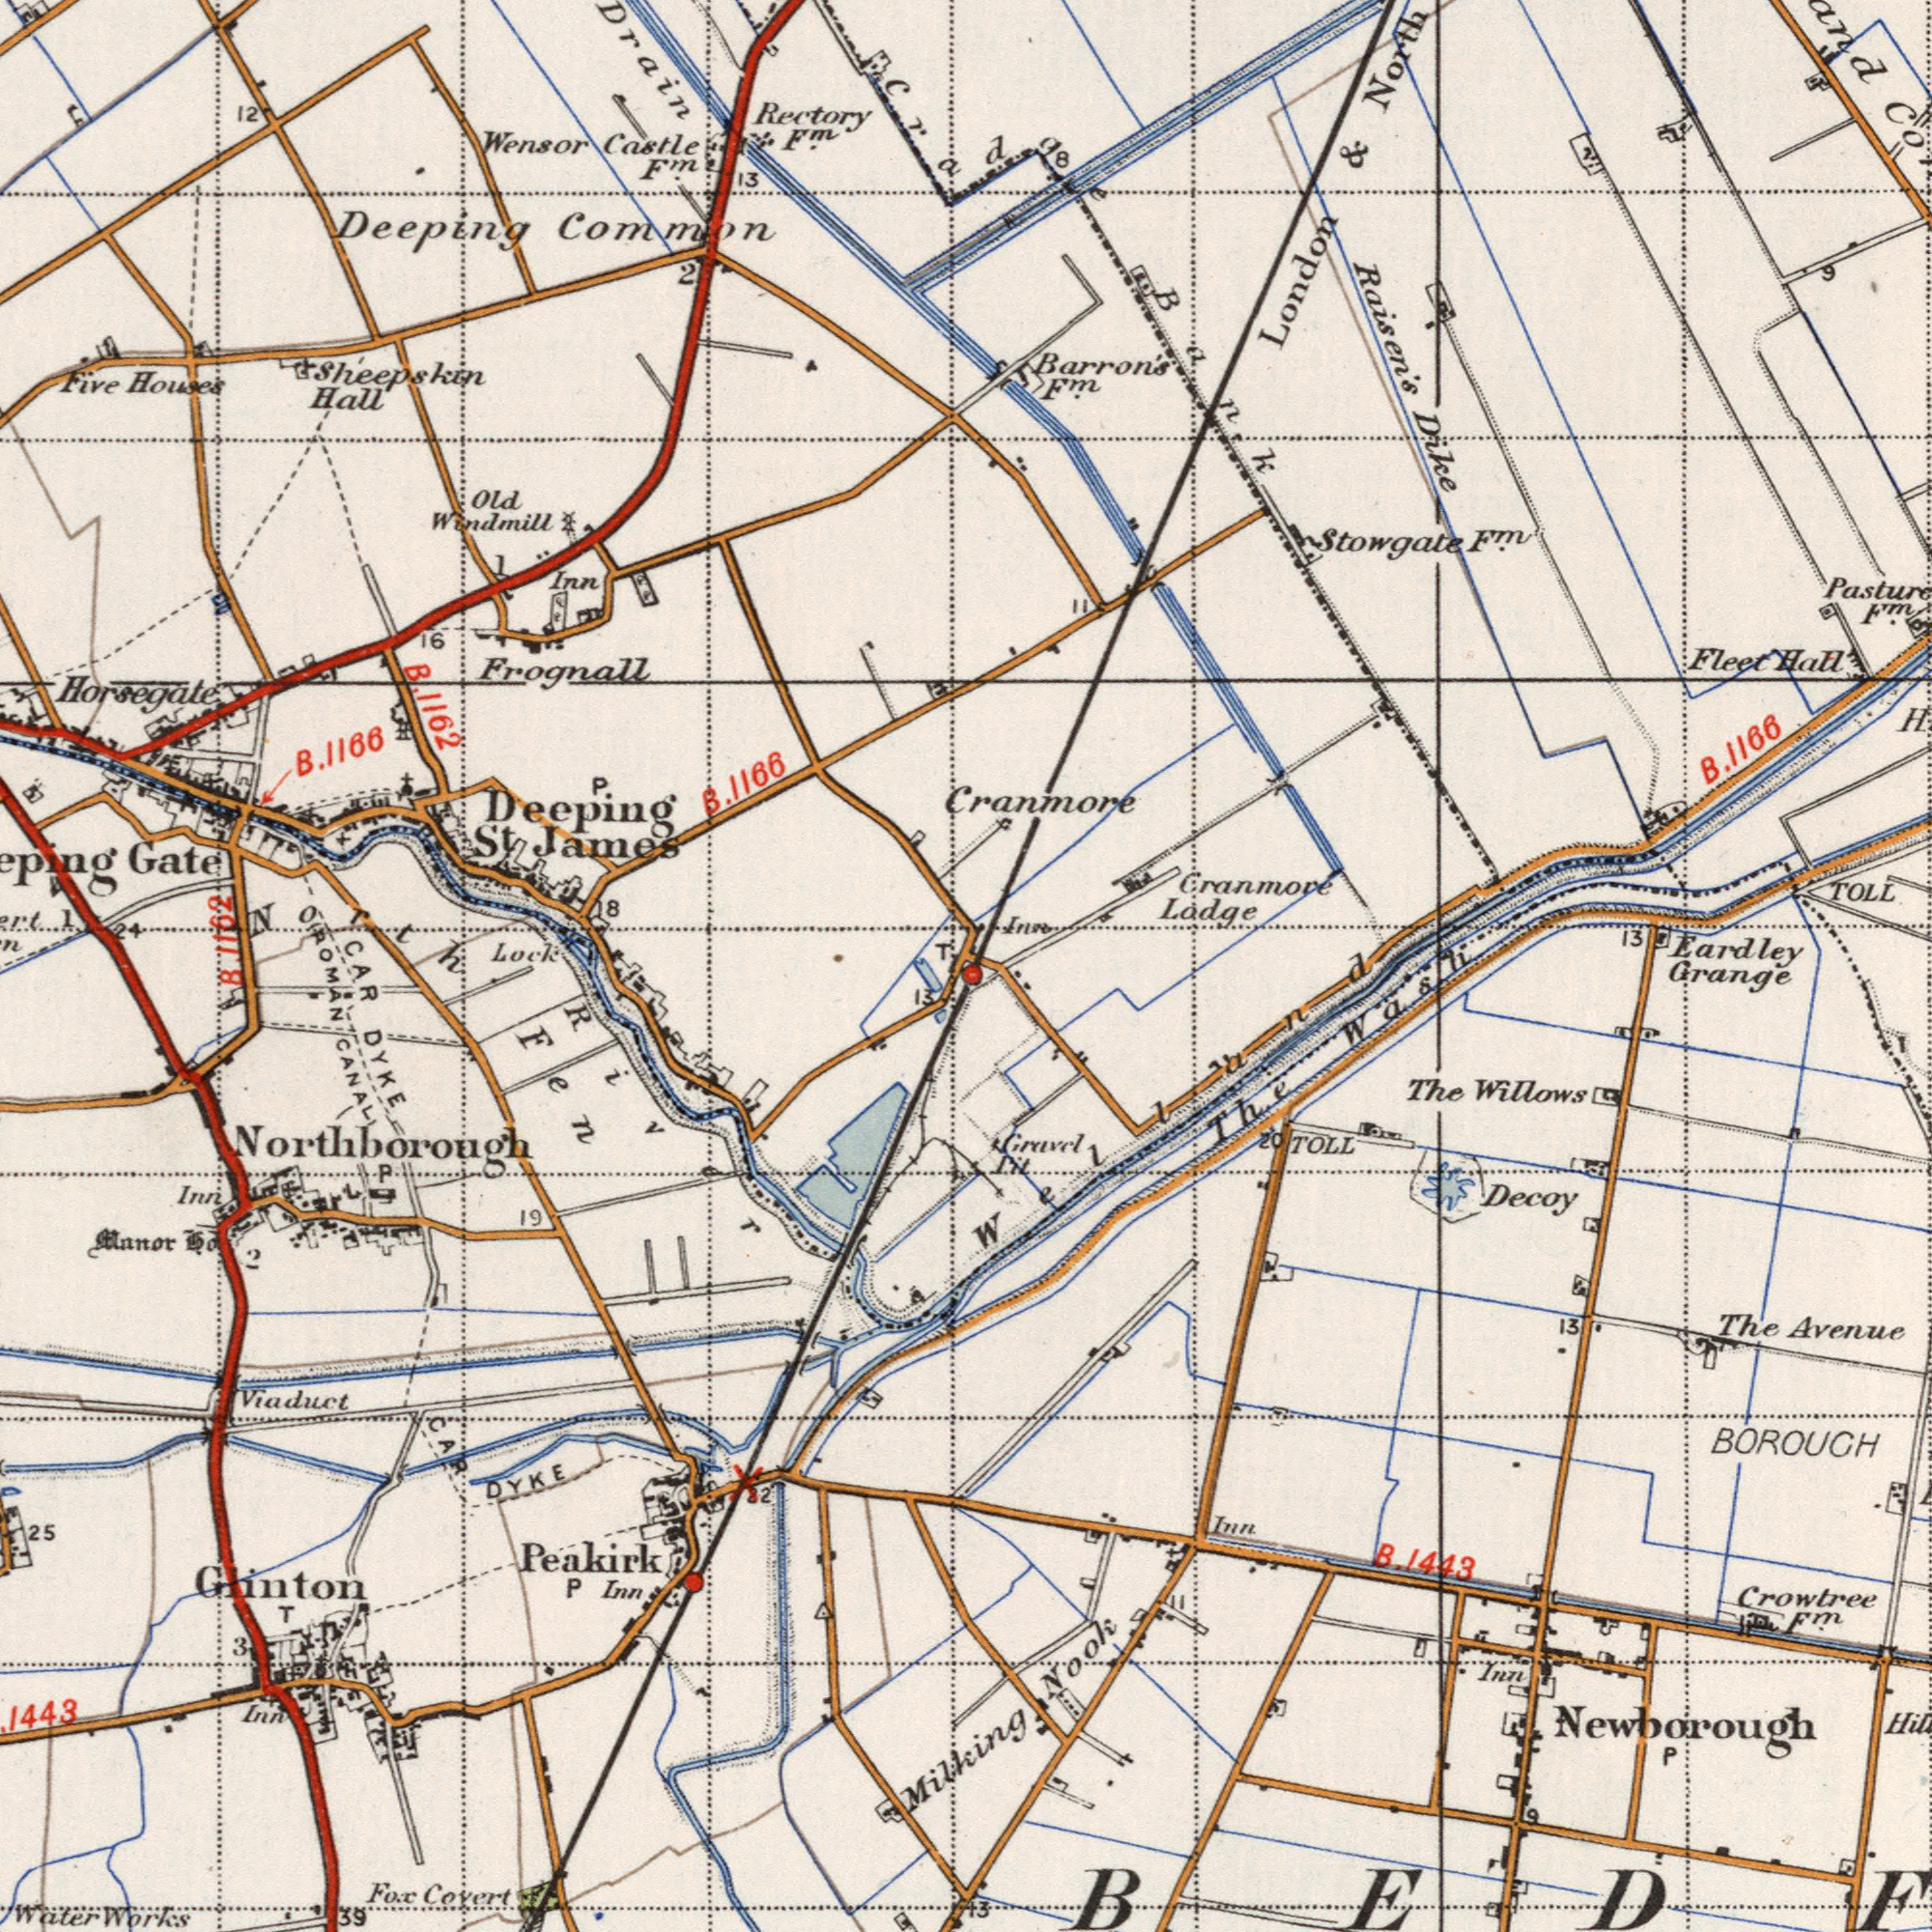What text is shown in the bottom-right quadrant? BOROUGH Crowtree Avenue The Grange Decoy The Inn Inn F<sup>m</sup>. Willows 13 P 9 Welland The Wash Gravel Pit 20 TOLL 13 B. 1443 Nook Newborough What text can you see in the bottom-left section? Glinton Peakirk DYKE Fox DYKE Viaduct Covert CANAL Works Water Northborough 39 CAR Inn 25 19 T Inn P 3 22 13 CAR B. River Fen Inn Manor 2 1443 Milking P ROMAN What text is shown in the top-right quadrant? Raisen's Dike TOLL Eardley & Fleet Hall North 13 London Cradge 8 Bank 9 Barron's F<sup>m</sup>. 11 Stowagate F<sup>m</sup>. Pasture F<sup>m</sup>. Cranmore Cranmore Ladge B. 1166 Inn What text is visible in the upper-left corner? Deeping Wensor Frognall Drain Five Lock Common Horsegate Rectory Castle Old Hall Inn 13 Windmill 16 Houses F<sup>m</sup>. F<sup>m</sup>. 1 2 Gate T Sheepskin 12 B. 1162 1 24 B. 1166 North P. Deeping St James B. 1166 8 1162 